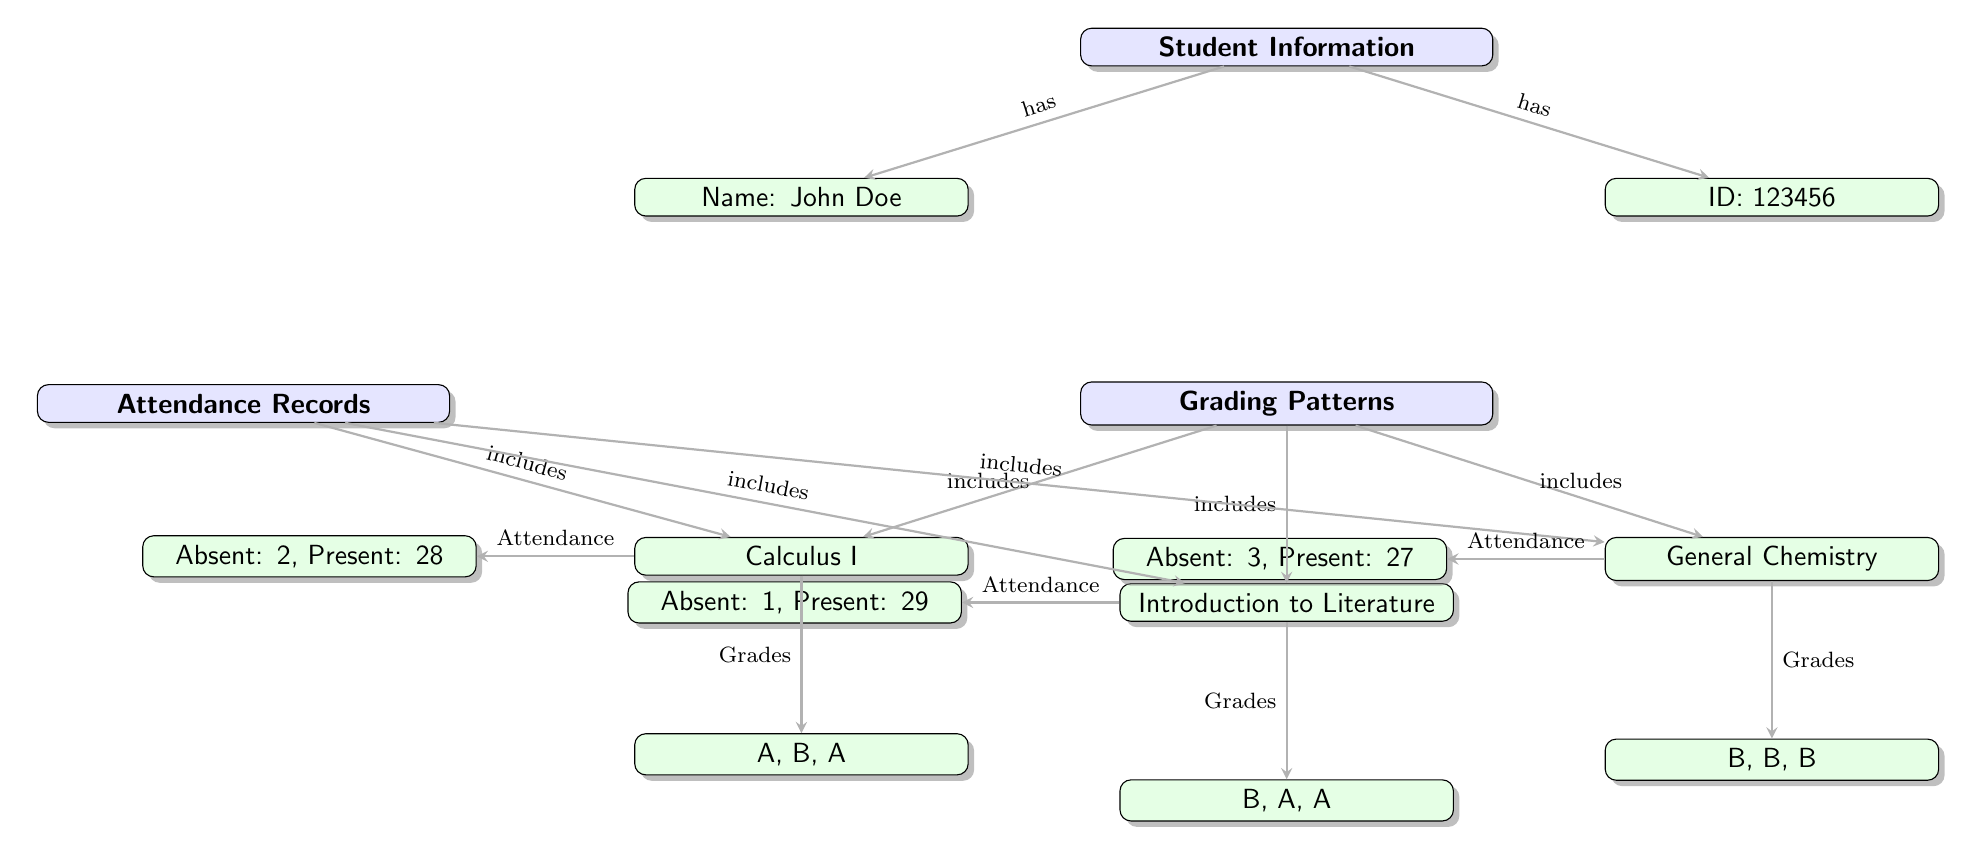What is the student's name? The diagram specifies the student's information, which includes their name. The name is listed directly below the "Student Information" node.
Answer: John Doe How many courses are included in the grading patterns? The grading patterns section of the diagram indicates three courses. Each course is represented as a leaf node under the "Grading Patterns" node.
Answer: 3 What grades did the student receive in Introduction to Literature? The grades for Introduction to Literature are shown directly beneath the course node in the diagram. The grades are listed as individual leaf nodes connected to the course.
Answer: B, A, A How many absences does the student have in General Chemistry? The attendance records for General Chemistry specify the number of absences directly next to the present counts. The absence count is explicitly shown in the attendance records section connected to the course node.
Answer: 3 Which course has the highest present-out-of-absent ratio? To find the highest present-out-of-absent ratio, we evaluate the attendance for each course. The calculation involves dividing the number of presents by the total absences. Introduction to Literature has 29 present versus 1 absent, giving a ratio of 29.
Answer: Introduction to Literature What relationship does the "Grading Patterns" node have with the course nodes? The "Grading Patterns" node has directed edges connecting it to each individual course node, indicating that the grading patterns include the grades for those specific courses. This can be determined by observing the arrows pointing from "Grading Patterns" to each course node.
Answer: includes What is the total number of presents recorded across all courses? By adding the present counts from each attendance record, we compute the total number of presents. The records show 28 in Calculus I, 29 in Introduction to Literature, and 27 in General Chemistry, yielding a total when summed together.
Answer: 84 Which grading pattern has the most B’s? By examining the grading patterns listed under each course, we can count the number of B's across courses. The pattern for General Chemistry shows three B's compared to other courses.
Answer: General Chemistry What is the ID of the student? The ID information is located directly below the "Student Information" node in the diagram, indicating the identifier assigned to the student.
Answer: 123456 